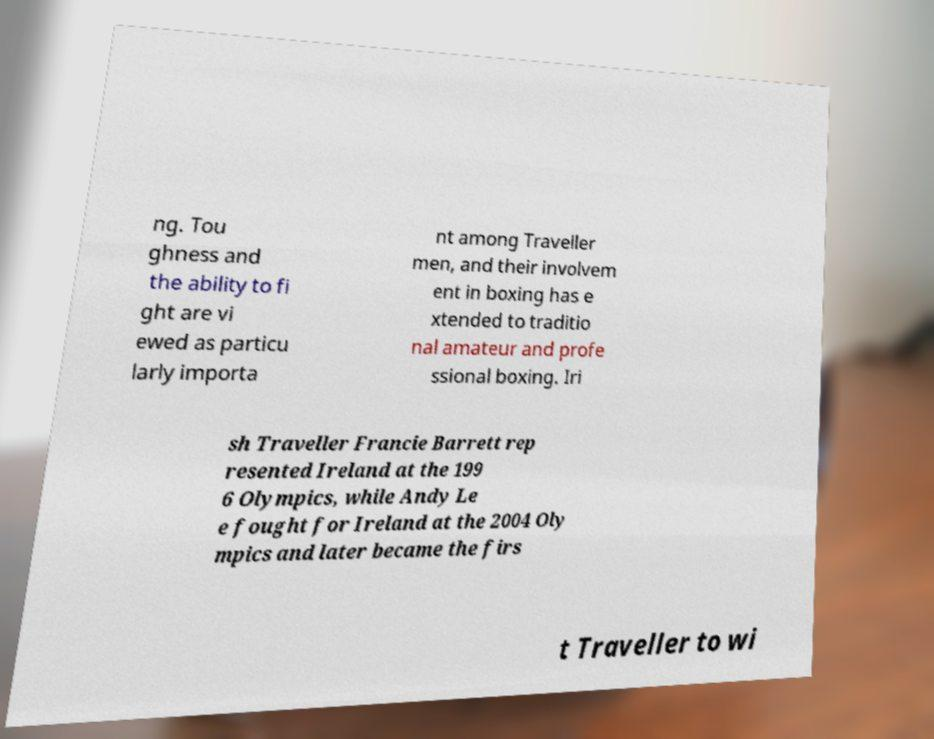For documentation purposes, I need the text within this image transcribed. Could you provide that? ng. Tou ghness and the ability to fi ght are vi ewed as particu larly importa nt among Traveller men, and their involvem ent in boxing has e xtended to traditio nal amateur and profe ssional boxing. Iri sh Traveller Francie Barrett rep resented Ireland at the 199 6 Olympics, while Andy Le e fought for Ireland at the 2004 Oly mpics and later became the firs t Traveller to wi 